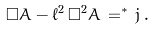<formula> <loc_0><loc_0><loc_500><loc_500>\square A - \ell ^ { 2 } \, \square ^ { 2 } A \, = ^ { * } { \, } j \, .</formula> 